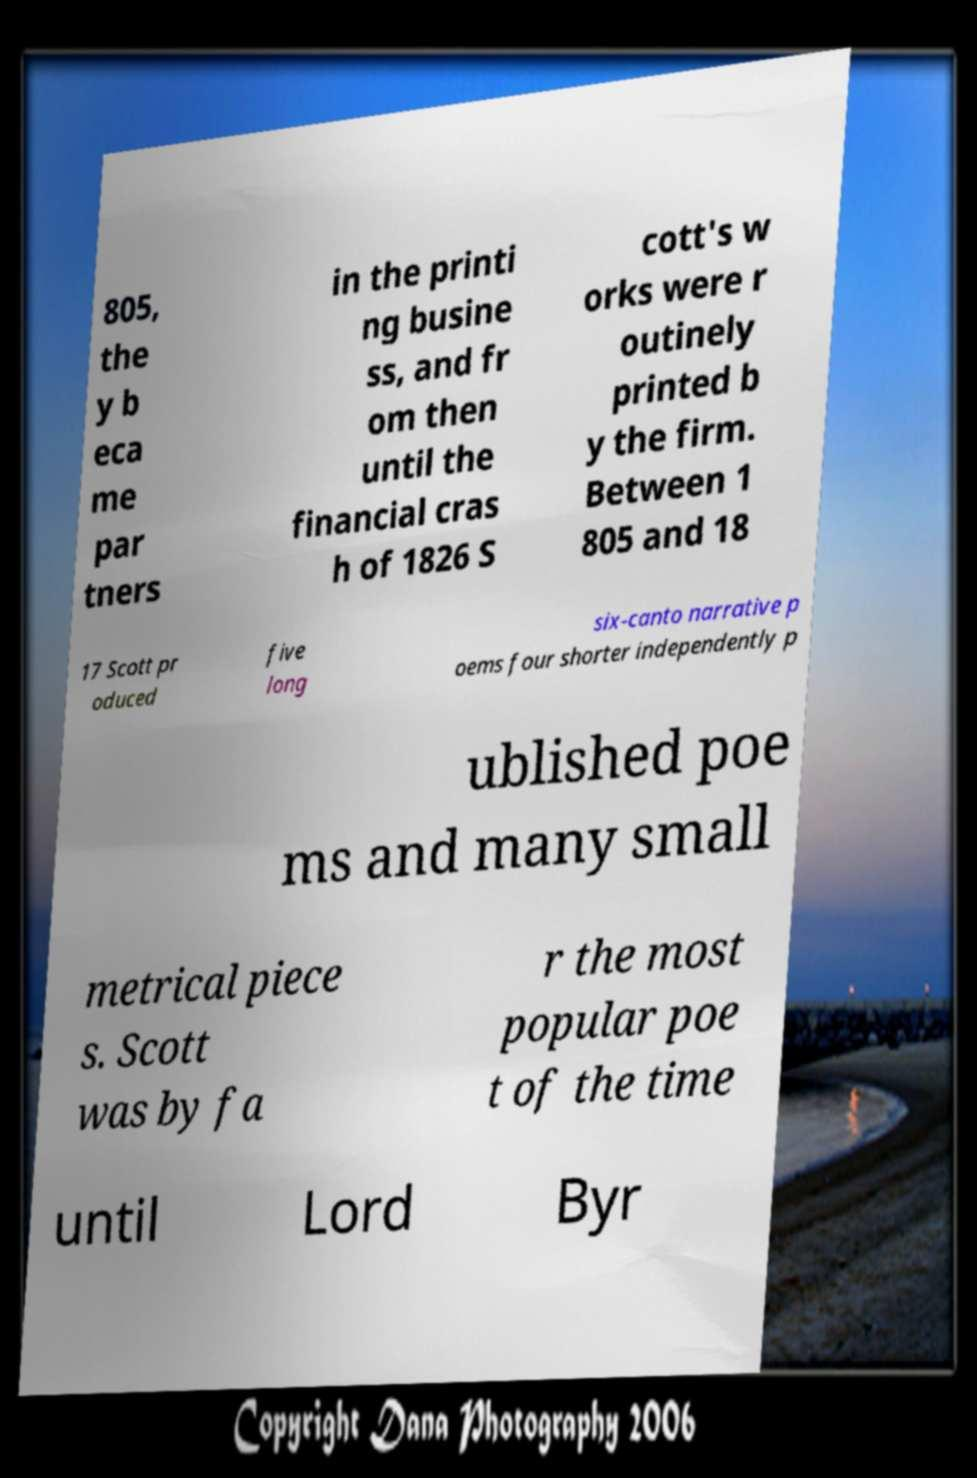Can you read and provide the text displayed in the image?This photo seems to have some interesting text. Can you extract and type it out for me? 805, the y b eca me par tners in the printi ng busine ss, and fr om then until the financial cras h of 1826 S cott's w orks were r outinely printed b y the firm. Between 1 805 and 18 17 Scott pr oduced five long six-canto narrative p oems four shorter independently p ublished poe ms and many small metrical piece s. Scott was by fa r the most popular poe t of the time until Lord Byr 